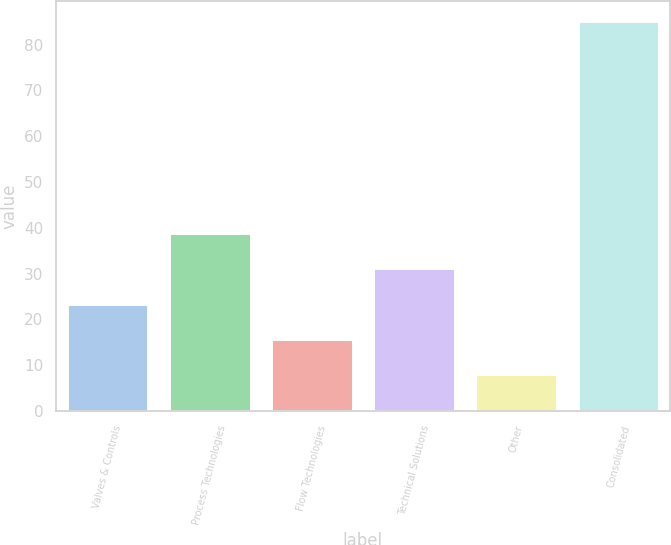<chart> <loc_0><loc_0><loc_500><loc_500><bar_chart><fcel>Valves & Controls<fcel>Process Technologies<fcel>Flow Technologies<fcel>Technical Solutions<fcel>Other<fcel>Consolidated<nl><fcel>23.44<fcel>38.88<fcel>15.72<fcel>31.16<fcel>8<fcel>85.2<nl></chart> 